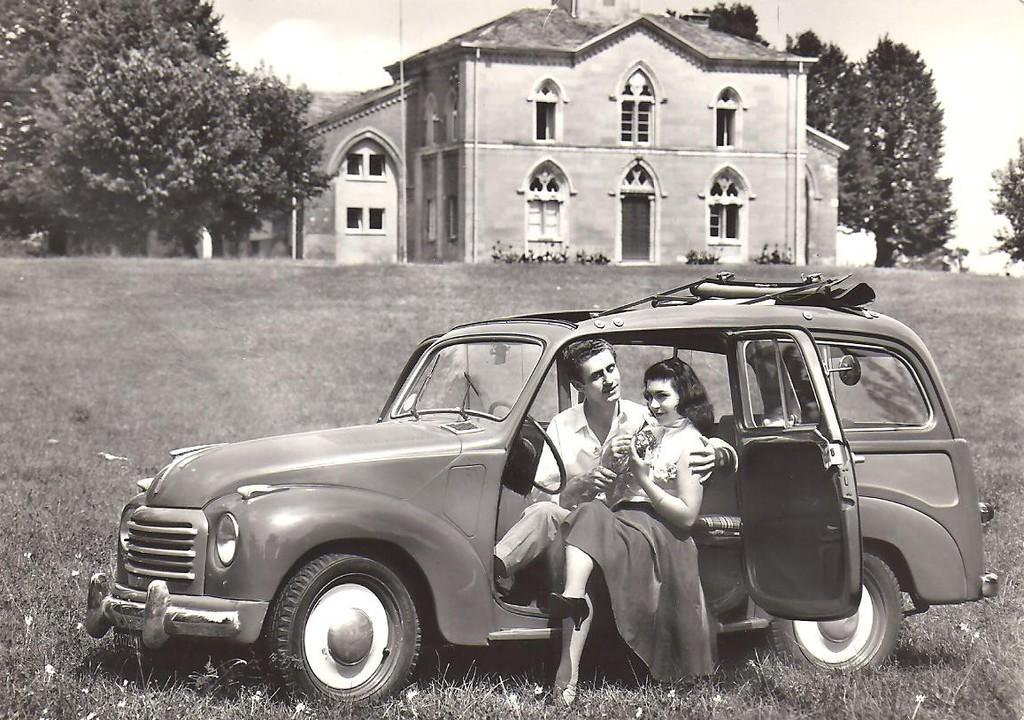Who is present in the image? There is a man and a woman in the image. What are the man and woman doing in the image? Both the man and woman are sitting in a car. What can be seen in the background of the image? There are trees and a building in the background of the image. What type of steel is used to construct the trucks in the image? There are no trucks present in the image, so it is not possible to determine the type of steel used in their construction. 